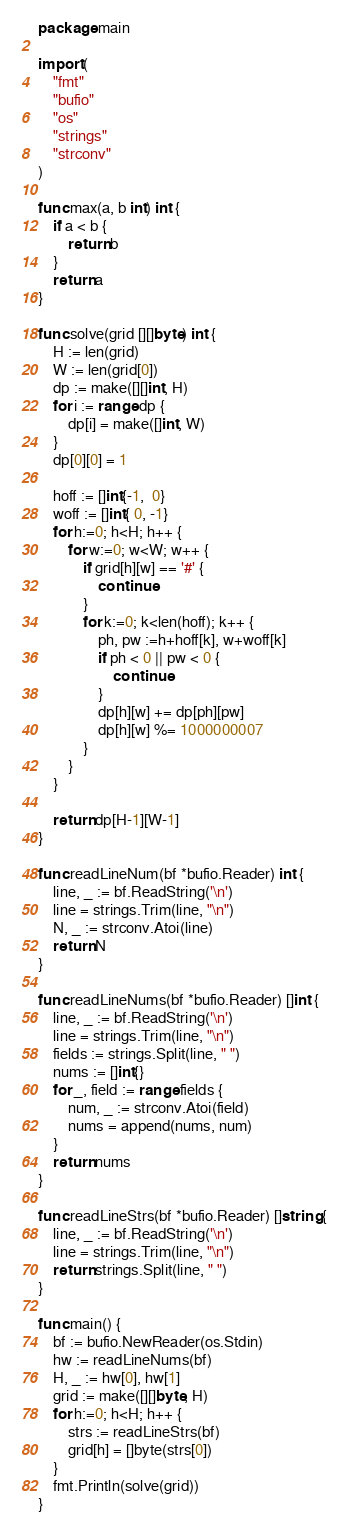<code> <loc_0><loc_0><loc_500><loc_500><_Go_>package main

import (
	"fmt"
	"bufio"
	"os"
	"strings"
	"strconv"
)

func max(a, b int) int {
	if a < b {
		return b
	}
	return a
}

func solve(grid [][]byte) int {
    H := len(grid)
    W := len(grid[0])
    dp := make([][]int, H)
    for i := range dp {
        dp[i] = make([]int, W)
    }
    dp[0][0] = 1

    hoff := []int{-1,  0}
    woff := []int{ 0, -1}
    for h:=0; h<H; h++ {
        for w:=0; w<W; w++ {
            if grid[h][w] == '#' {
                continue
            }
            for k:=0; k<len(hoff); k++ {
                ph, pw :=h+hoff[k], w+woff[k]
                if ph < 0 || pw < 0 {
                    continue
                }
                dp[h][w] += dp[ph][pw]
                dp[h][w] %= 1000000007
            }
        }
    }

    return dp[H-1][W-1]
}

func readLineNum(bf *bufio.Reader) int {
	line, _ := bf.ReadString('\n')
	line = strings.Trim(line, "\n")
	N, _ := strconv.Atoi(line)
	return N
}

func readLineNums(bf *bufio.Reader) []int {
	line, _ := bf.ReadString('\n')
	line = strings.Trim(line, "\n")
	fields := strings.Split(line, " ")
	nums := []int{}
	for _, field := range fields {
		num, _ := strconv.Atoi(field)
		nums = append(nums, num)
	}
	return nums
}

func readLineStrs(bf *bufio.Reader) []string {
	line, _ := bf.ReadString('\n')
	line = strings.Trim(line, "\n")
	return strings.Split(line, " ")
}

func main() {
	bf := bufio.NewReader(os.Stdin)
	hw := readLineNums(bf)
    H, _ := hw[0], hw[1]
    grid := make([][]byte, H)
    for h:=0; h<H; h++ {
        strs := readLineStrs(bf)
        grid[h] = []byte(strs[0])
    }
    fmt.Println(solve(grid))
}
</code> 